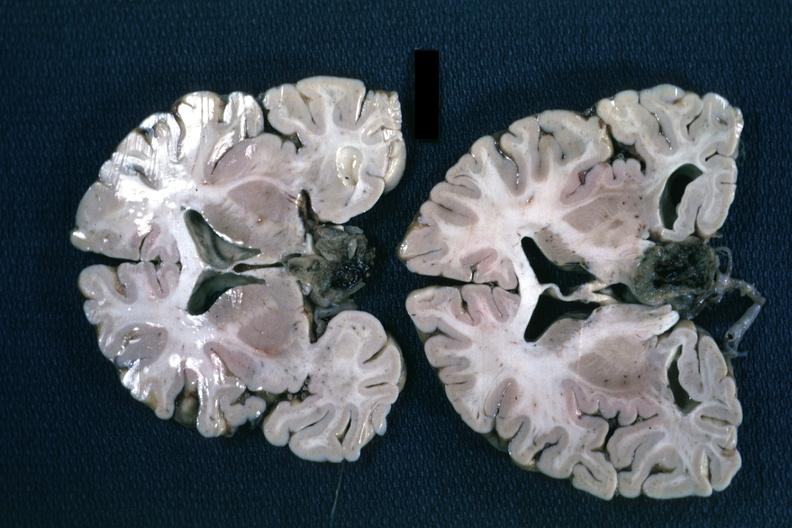s pituitary present?
Answer the question using a single word or phrase. Yes 